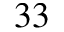<formula> <loc_0><loc_0><loc_500><loc_500>^ { 3 3 }</formula> 